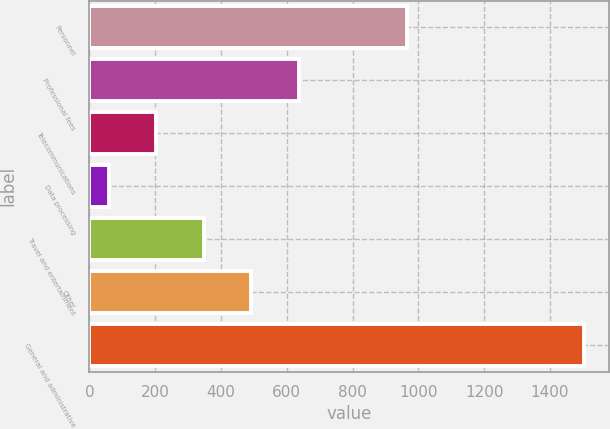<chart> <loc_0><loc_0><loc_500><loc_500><bar_chart><fcel>Personnel<fcel>Professional fees<fcel>Telecommunications<fcel>Data processing<fcel>Travel and entertainment<fcel>Other<fcel>General and administrative<nl><fcel>966<fcel>637.4<fcel>203.6<fcel>59<fcel>348.2<fcel>492.8<fcel>1505<nl></chart> 